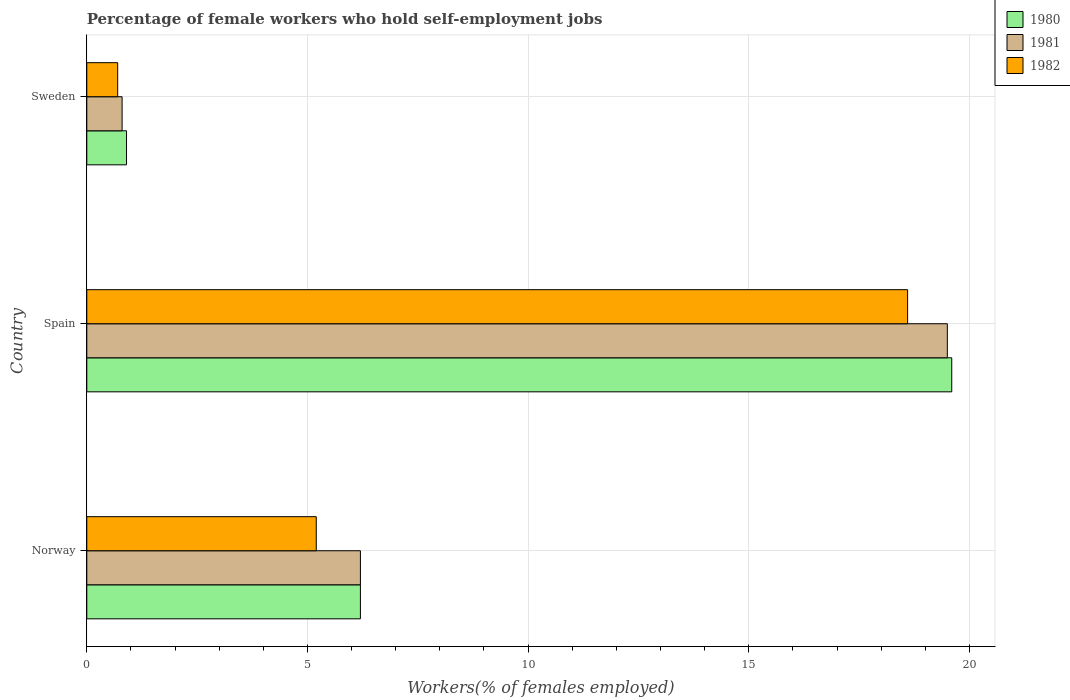How many different coloured bars are there?
Provide a succinct answer. 3. How many groups of bars are there?
Keep it short and to the point. 3. Are the number of bars per tick equal to the number of legend labels?
Give a very brief answer. Yes. How many bars are there on the 2nd tick from the bottom?
Your response must be concise. 3. What is the label of the 2nd group of bars from the top?
Make the answer very short. Spain. In how many cases, is the number of bars for a given country not equal to the number of legend labels?
Provide a short and direct response. 0. What is the percentage of self-employed female workers in 1980 in Spain?
Ensure brevity in your answer.  19.6. Across all countries, what is the maximum percentage of self-employed female workers in 1982?
Give a very brief answer. 18.6. Across all countries, what is the minimum percentage of self-employed female workers in 1982?
Give a very brief answer. 0.7. In which country was the percentage of self-employed female workers in 1982 maximum?
Offer a very short reply. Spain. What is the total percentage of self-employed female workers in 1982 in the graph?
Provide a succinct answer. 24.5. What is the difference between the percentage of self-employed female workers in 1980 in Norway and that in Sweden?
Make the answer very short. 5.3. What is the difference between the percentage of self-employed female workers in 1980 in Spain and the percentage of self-employed female workers in 1981 in Sweden?
Give a very brief answer. 18.8. What is the average percentage of self-employed female workers in 1981 per country?
Provide a succinct answer. 8.83. What is the difference between the percentage of self-employed female workers in 1981 and percentage of self-employed female workers in 1982 in Sweden?
Offer a terse response. 0.1. In how many countries, is the percentage of self-employed female workers in 1981 greater than 6 %?
Your response must be concise. 2. What is the ratio of the percentage of self-employed female workers in 1981 in Norway to that in Sweden?
Offer a terse response. 7.75. Is the percentage of self-employed female workers in 1981 in Norway less than that in Spain?
Provide a succinct answer. Yes. What is the difference between the highest and the second highest percentage of self-employed female workers in 1981?
Make the answer very short. 13.3. What is the difference between the highest and the lowest percentage of self-employed female workers in 1981?
Ensure brevity in your answer.  18.7. What does the 1st bar from the top in Sweden represents?
Ensure brevity in your answer.  1982. How many bars are there?
Keep it short and to the point. 9. Are all the bars in the graph horizontal?
Keep it short and to the point. Yes. What is the difference between two consecutive major ticks on the X-axis?
Your response must be concise. 5. Are the values on the major ticks of X-axis written in scientific E-notation?
Your response must be concise. No. How many legend labels are there?
Give a very brief answer. 3. What is the title of the graph?
Offer a terse response. Percentage of female workers who hold self-employment jobs. Does "2005" appear as one of the legend labels in the graph?
Offer a very short reply. No. What is the label or title of the X-axis?
Your answer should be very brief. Workers(% of females employed). What is the label or title of the Y-axis?
Offer a very short reply. Country. What is the Workers(% of females employed) in 1980 in Norway?
Offer a terse response. 6.2. What is the Workers(% of females employed) of 1981 in Norway?
Provide a short and direct response. 6.2. What is the Workers(% of females employed) of 1982 in Norway?
Provide a succinct answer. 5.2. What is the Workers(% of females employed) of 1980 in Spain?
Your answer should be very brief. 19.6. What is the Workers(% of females employed) in 1981 in Spain?
Your answer should be very brief. 19.5. What is the Workers(% of females employed) in 1982 in Spain?
Make the answer very short. 18.6. What is the Workers(% of females employed) in 1980 in Sweden?
Make the answer very short. 0.9. What is the Workers(% of females employed) of 1981 in Sweden?
Make the answer very short. 0.8. What is the Workers(% of females employed) in 1982 in Sweden?
Your answer should be compact. 0.7. Across all countries, what is the maximum Workers(% of females employed) of 1980?
Provide a succinct answer. 19.6. Across all countries, what is the maximum Workers(% of females employed) of 1982?
Make the answer very short. 18.6. Across all countries, what is the minimum Workers(% of females employed) of 1980?
Make the answer very short. 0.9. Across all countries, what is the minimum Workers(% of females employed) in 1981?
Ensure brevity in your answer.  0.8. Across all countries, what is the minimum Workers(% of females employed) in 1982?
Ensure brevity in your answer.  0.7. What is the total Workers(% of females employed) of 1980 in the graph?
Offer a very short reply. 26.7. What is the difference between the Workers(% of females employed) in 1980 in Norway and that in Spain?
Your answer should be very brief. -13.4. What is the difference between the Workers(% of females employed) in 1982 in Norway and that in Spain?
Offer a terse response. -13.4. What is the difference between the Workers(% of females employed) in 1981 in Spain and that in Sweden?
Provide a succinct answer. 18.7. What is the difference between the Workers(% of females employed) of 1980 in Norway and the Workers(% of females employed) of 1981 in Spain?
Offer a very short reply. -13.3. What is the difference between the Workers(% of females employed) of 1980 in Norway and the Workers(% of females employed) of 1981 in Sweden?
Your answer should be very brief. 5.4. What is the difference between the Workers(% of females employed) of 1980 in Norway and the Workers(% of females employed) of 1982 in Sweden?
Your response must be concise. 5.5. What is the average Workers(% of females employed) of 1981 per country?
Provide a short and direct response. 8.83. What is the average Workers(% of females employed) of 1982 per country?
Your answer should be compact. 8.17. What is the difference between the Workers(% of females employed) in 1980 and Workers(% of females employed) in 1981 in Norway?
Your answer should be very brief. 0. What is the difference between the Workers(% of females employed) of 1980 and Workers(% of females employed) of 1981 in Spain?
Your answer should be compact. 0.1. What is the difference between the Workers(% of females employed) in 1980 and Workers(% of females employed) in 1981 in Sweden?
Offer a terse response. 0.1. What is the ratio of the Workers(% of females employed) in 1980 in Norway to that in Spain?
Offer a very short reply. 0.32. What is the ratio of the Workers(% of females employed) of 1981 in Norway to that in Spain?
Provide a short and direct response. 0.32. What is the ratio of the Workers(% of females employed) of 1982 in Norway to that in Spain?
Offer a terse response. 0.28. What is the ratio of the Workers(% of females employed) in 1980 in Norway to that in Sweden?
Give a very brief answer. 6.89. What is the ratio of the Workers(% of females employed) of 1981 in Norway to that in Sweden?
Make the answer very short. 7.75. What is the ratio of the Workers(% of females employed) in 1982 in Norway to that in Sweden?
Make the answer very short. 7.43. What is the ratio of the Workers(% of females employed) of 1980 in Spain to that in Sweden?
Your answer should be very brief. 21.78. What is the ratio of the Workers(% of females employed) of 1981 in Spain to that in Sweden?
Provide a succinct answer. 24.38. What is the ratio of the Workers(% of females employed) in 1982 in Spain to that in Sweden?
Your answer should be compact. 26.57. What is the difference between the highest and the second highest Workers(% of females employed) of 1980?
Offer a terse response. 13.4. What is the difference between the highest and the second highest Workers(% of females employed) in 1981?
Make the answer very short. 13.3. 